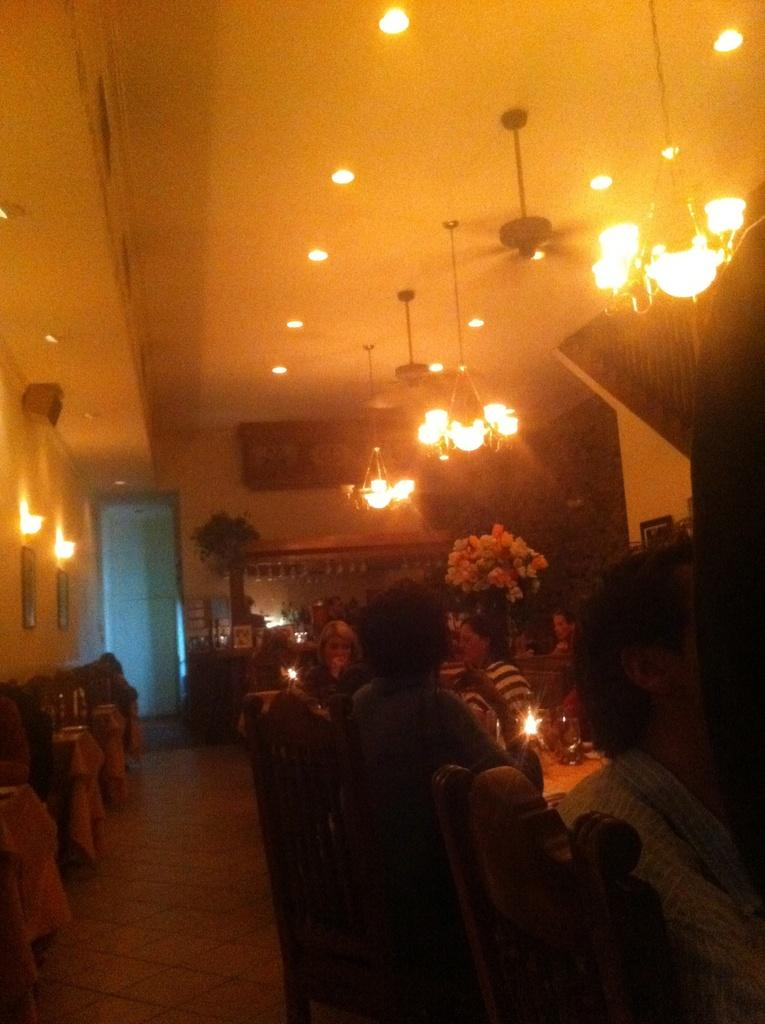Where was the image taken? The image was taken in a restaurant. What are the people in the image doing? The people in the image are sitting in chairs. What can be seen above the people in the image? There is a roof visible in the image. What type of lighting is present in the restaurant? Lights are hanged in the restaurant. What is the surface beneath the people in the image? There is a floor visible in the image. What type of soup is being served in the image? There is no soup present in the image. The image does not show any food being served. 